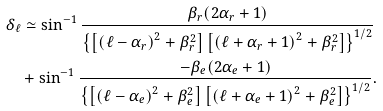Convert formula to latex. <formula><loc_0><loc_0><loc_500><loc_500>& \delta _ { \ell } \simeq \sin ^ { - 1 } \frac { \beta _ { r } ( 2 \alpha _ { r } + 1 ) } { \left \{ \left [ \left ( \ell - \alpha _ { r } \right ) ^ { 2 } + \beta _ { r } ^ { 2 } \right ] \left [ \left ( \ell + \alpha _ { r } + 1 \right ) ^ { 2 } + \beta _ { r } ^ { 2 } \right ] \right \} ^ { 1 / 2 } } \\ & \quad + \sin ^ { - 1 } \frac { - \beta _ { e } ( 2 \alpha _ { e } + 1 ) } { \left \{ \left [ \left ( \ell - \alpha _ { e } \right ) ^ { 2 } + \beta _ { e } ^ { 2 } \right ] \left [ \left ( \ell + \alpha _ { e } + 1 \right ) ^ { 2 } + \beta _ { e } ^ { 2 } \right ] \right \} ^ { 1 / 2 } } .</formula> 